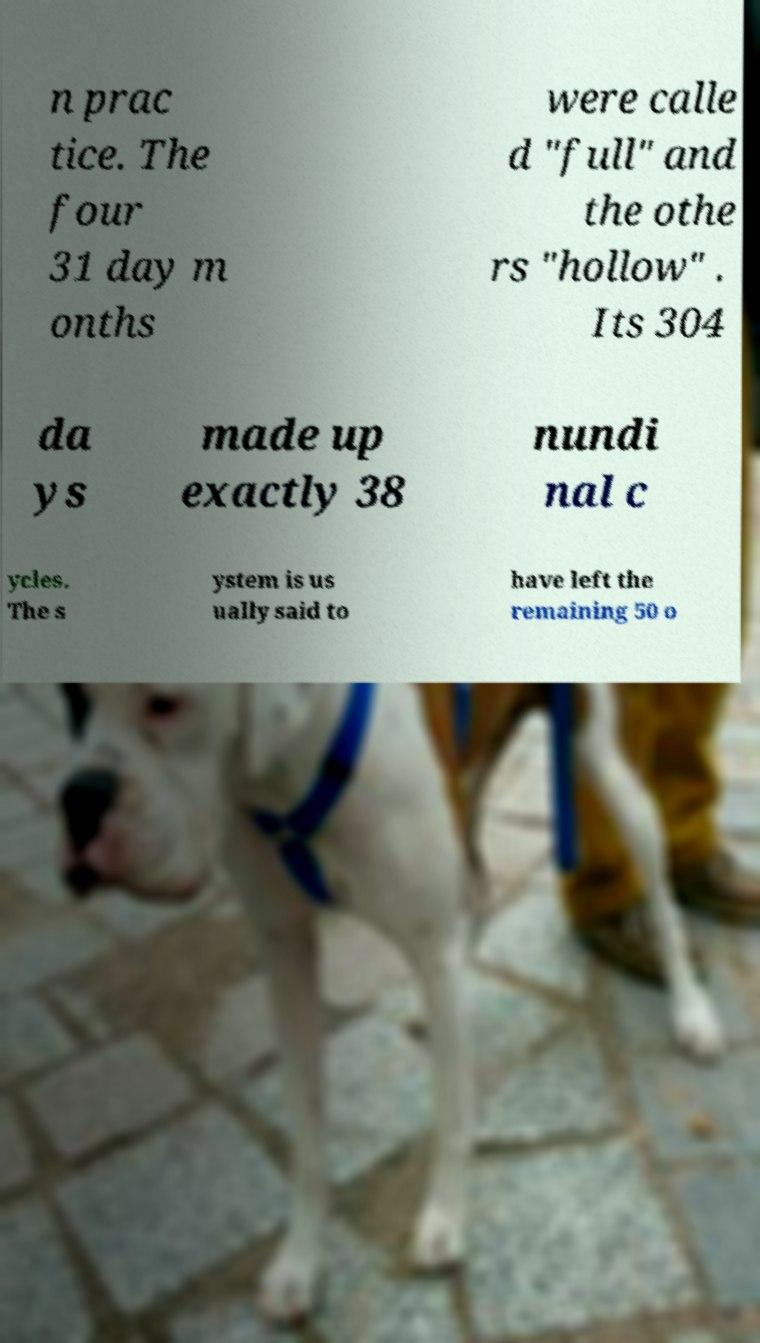Could you assist in decoding the text presented in this image and type it out clearly? n prac tice. The four 31 day m onths were calle d "full" and the othe rs "hollow" . Its 304 da ys made up exactly 38 nundi nal c ycles. The s ystem is us ually said to have left the remaining 50 o 